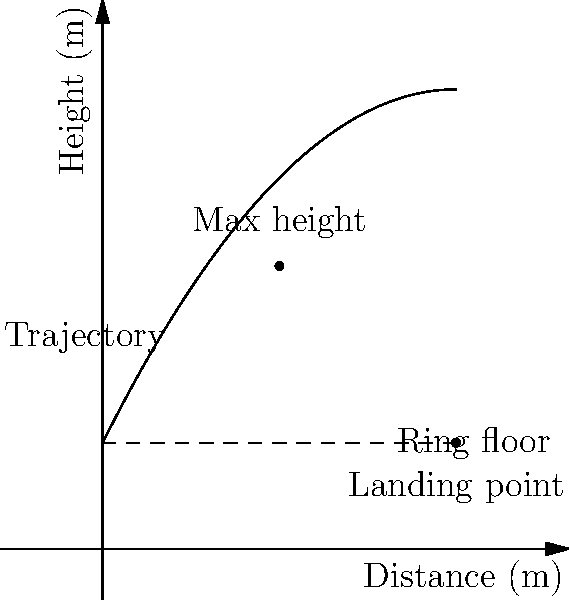In a wrestling video game, you need to model the trajectory of a wrestler performing a high-flying move. The wrestler jumps from a 3-meter-high turnbuckle and lands 10 meters away. The trajectory can be modeled by the polynomial function $h(x) = -ax^2 + bx + c$, where $x$ is the horizontal distance and $h(x)$ is the height. Given that the maximum height reached is 8 meters at $x = 5$, determine the values of $a$, $b$, and $c$. Let's approach this step-by-step:

1) We know that $h(x) = -ax^2 + bx + c$

2) Given information:
   - The wrestler starts at height 3m: $h(0) = 3$
   - The wrestler lands 10m away at height 3m: $h(10) = 3$
   - The maximum height of 8m is reached at $x = 5$

3) Using $h(0) = 3$:
   $3 = -a(0)^2 + b(0) + c$
   $c = 3$

4) At the maximum point $(5, 8)$, the derivative $h'(x) = 0$:
   $h'(x) = -2ax + b$
   $0 = -2a(5) + b$
   $b = 10a$

5) Using the maximum point $(5, 8)$:
   $8 = -a(5)^2 + b(5) + 3$
   $8 = -25a + 50a + 3$
   $5 = 25a$
   $a = 0.2$

6) Since $b = 10a$ and $a = 0.2$:
   $b = 10(0.2) = 2$

7) Verify using $h(10) = 3$:
   $3 = -0.2(10)^2 + 2(10) + 3$
   $3 = -20 + 20 + 3$
   $3 = 3$ (checks out)

Therefore, $a = 0.2$, $b = 2$, and $c = 3$.
Answer: $a = 0.2$, $b = 2$, $c = 3$ 